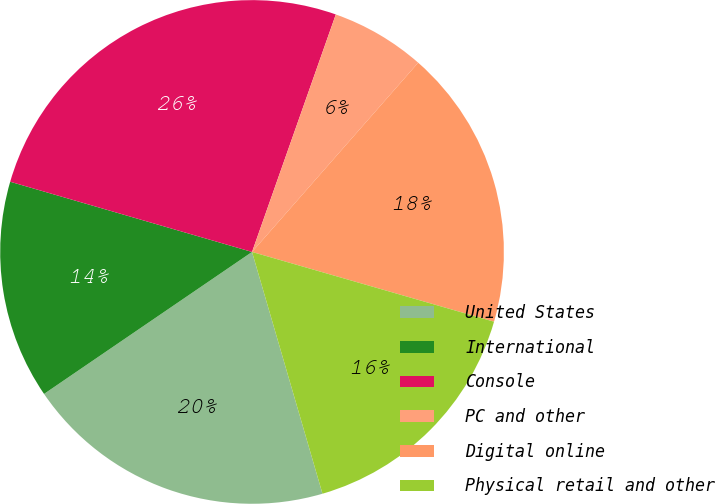<chart> <loc_0><loc_0><loc_500><loc_500><pie_chart><fcel>United States<fcel>International<fcel>Console<fcel>PC and other<fcel>Digital online<fcel>Physical retail and other<nl><fcel>19.98%<fcel>14.03%<fcel>25.9%<fcel>6.07%<fcel>18.0%<fcel>16.02%<nl></chart> 